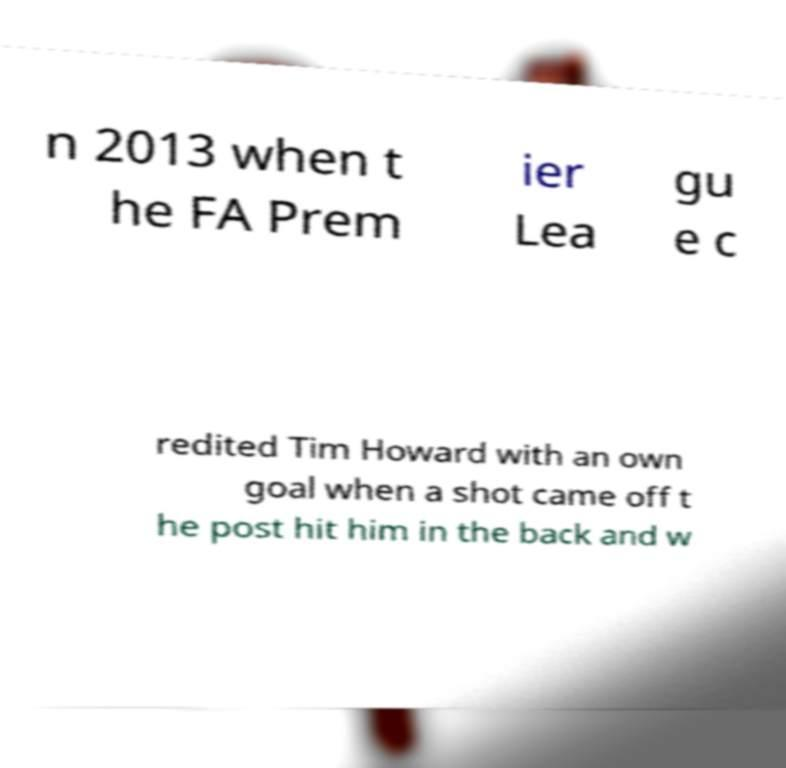I need the written content from this picture converted into text. Can you do that? n 2013 when t he FA Prem ier Lea gu e c redited Tim Howard with an own goal when a shot came off t he post hit him in the back and w 